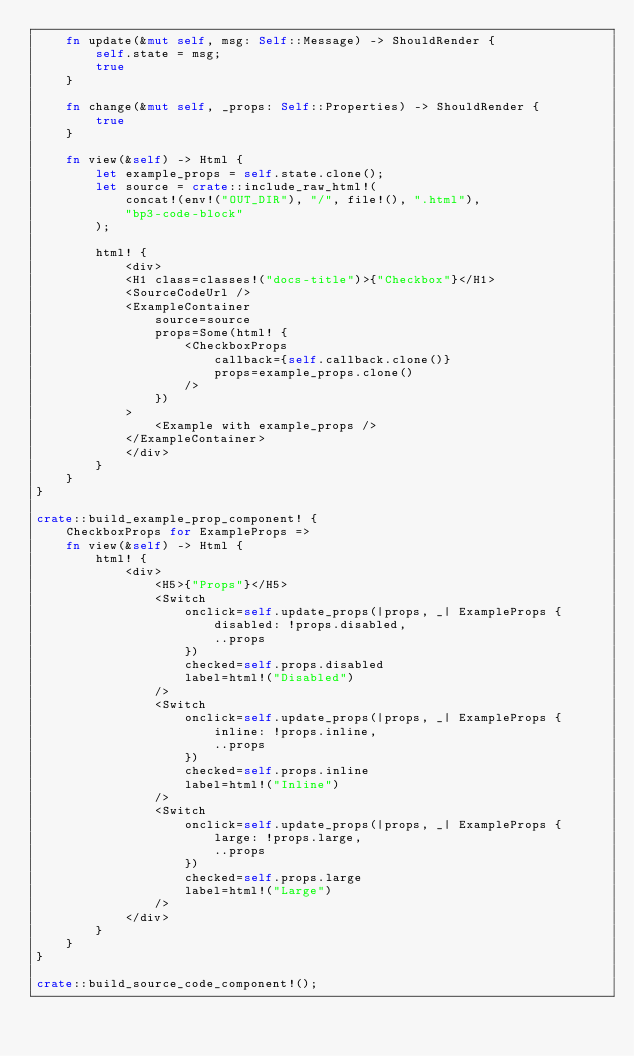<code> <loc_0><loc_0><loc_500><loc_500><_Rust_>    fn update(&mut self, msg: Self::Message) -> ShouldRender {
        self.state = msg;
        true
    }

    fn change(&mut self, _props: Self::Properties) -> ShouldRender {
        true
    }

    fn view(&self) -> Html {
        let example_props = self.state.clone();
        let source = crate::include_raw_html!(
            concat!(env!("OUT_DIR"), "/", file!(), ".html"),
            "bp3-code-block"
        );

        html! {
            <div>
            <H1 class=classes!("docs-title")>{"Checkbox"}</H1>
            <SourceCodeUrl />
            <ExampleContainer
                source=source
                props=Some(html! {
                    <CheckboxProps
                        callback={self.callback.clone()}
                        props=example_props.clone()
                    />
                })
            >
                <Example with example_props />
            </ExampleContainer>
            </div>
        }
    }
}

crate::build_example_prop_component! {
    CheckboxProps for ExampleProps =>
    fn view(&self) -> Html {
        html! {
            <div>
                <H5>{"Props"}</H5>
                <Switch
                    onclick=self.update_props(|props, _| ExampleProps {
                        disabled: !props.disabled,
                        ..props
                    })
                    checked=self.props.disabled
                    label=html!("Disabled")
                />
                <Switch
                    onclick=self.update_props(|props, _| ExampleProps {
                        inline: !props.inline,
                        ..props
                    })
                    checked=self.props.inline
                    label=html!("Inline")
                />
                <Switch
                    onclick=self.update_props(|props, _| ExampleProps {
                        large: !props.large,
                        ..props
                    })
                    checked=self.props.large
                    label=html!("Large")
                />
            </div>
        }
    }
}

crate::build_source_code_component!();
</code> 